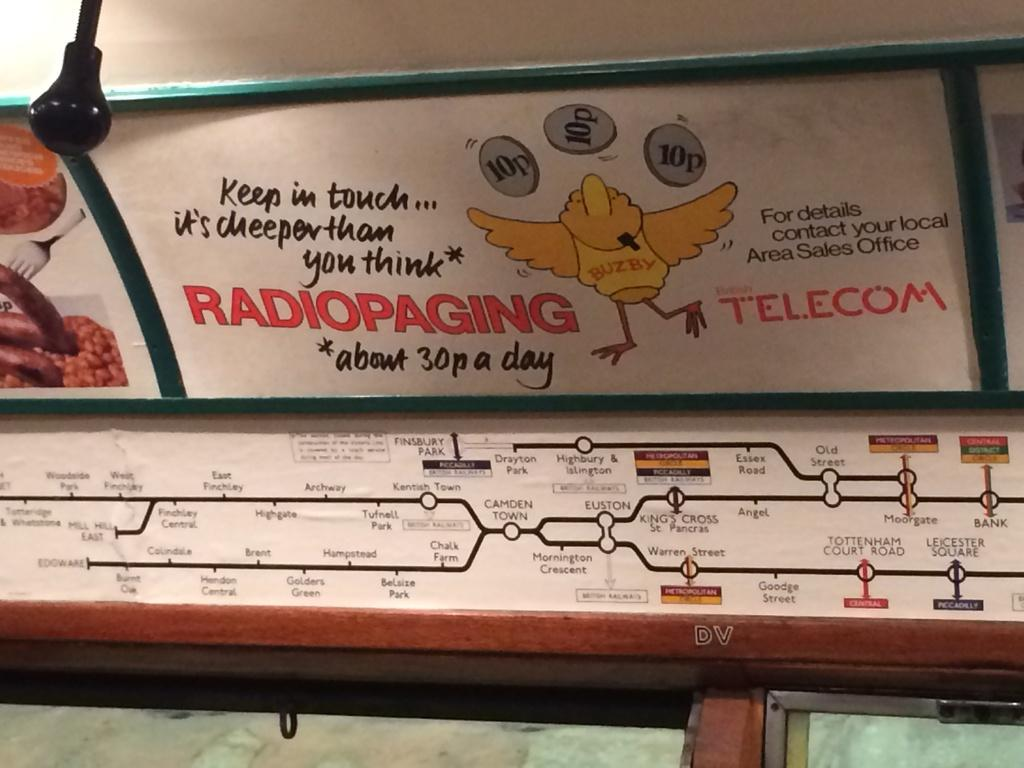<image>
Render a clear and concise summary of the photo. A Tube map in London shows stops such as Tottenham Court Road. 